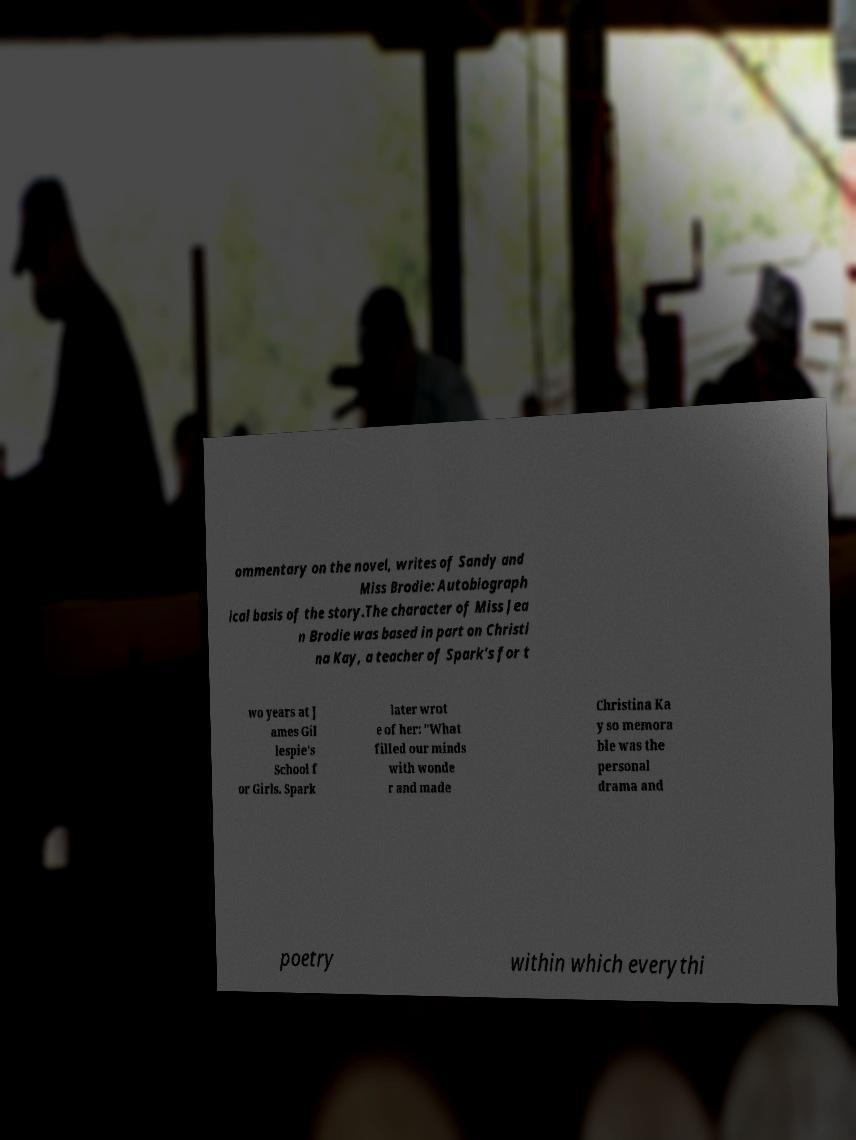There's text embedded in this image that I need extracted. Can you transcribe it verbatim? ommentary on the novel, writes of Sandy and Miss Brodie: Autobiograph ical basis of the story.The character of Miss Jea n Brodie was based in part on Christi na Kay, a teacher of Spark's for t wo years at J ames Gil lespie's School f or Girls. Spark later wrot e of her: "What filled our minds with wonde r and made Christina Ka y so memora ble was the personal drama and poetry within which everythi 